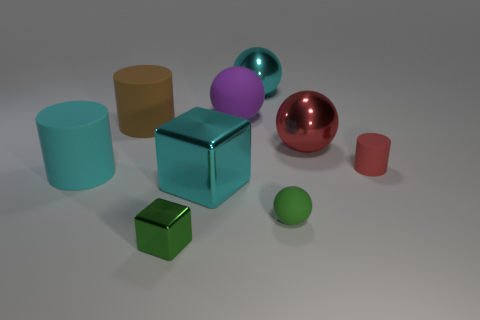What size is the cyan thing that is the same shape as the brown object?
Your answer should be very brief. Large. Is there a big cyan metallic object in front of the cylinder that is left of the big brown rubber cylinder?
Make the answer very short. Yes. Is the tiny ball the same color as the tiny metallic thing?
Your answer should be compact. Yes. How many other objects are there of the same shape as the small shiny thing?
Make the answer very short. 1. Is the number of cyan things on the left side of the small metallic thing greater than the number of green blocks on the right side of the tiny matte sphere?
Make the answer very short. Yes. Do the cyan metallic object in front of the purple ball and the red thing in front of the large red metallic ball have the same size?
Keep it short and to the point. No. The big brown thing has what shape?
Your response must be concise. Cylinder. There is a ball that is the same color as the big cube; what size is it?
Provide a short and direct response. Large. What is the color of the other block that is the same material as the cyan cube?
Offer a very short reply. Green. Are the large cyan cube and the cylinder that is in front of the small red thing made of the same material?
Offer a very short reply. No. 